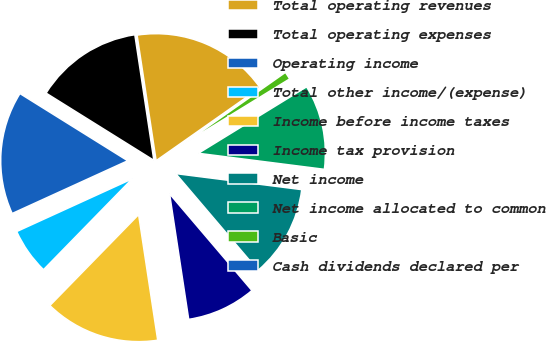<chart> <loc_0><loc_0><loc_500><loc_500><pie_chart><fcel>Total operating revenues<fcel>Total operating expenses<fcel>Operating income<fcel>Total other income/(expense)<fcel>Income before income taxes<fcel>Income tax provision<fcel>Net income<fcel>Net income allocated to common<fcel>Basic<fcel>Cash dividends declared per<nl><fcel>17.65%<fcel>13.73%<fcel>15.69%<fcel>5.88%<fcel>14.71%<fcel>8.82%<fcel>11.76%<fcel>10.78%<fcel>0.98%<fcel>0.0%<nl></chart> 